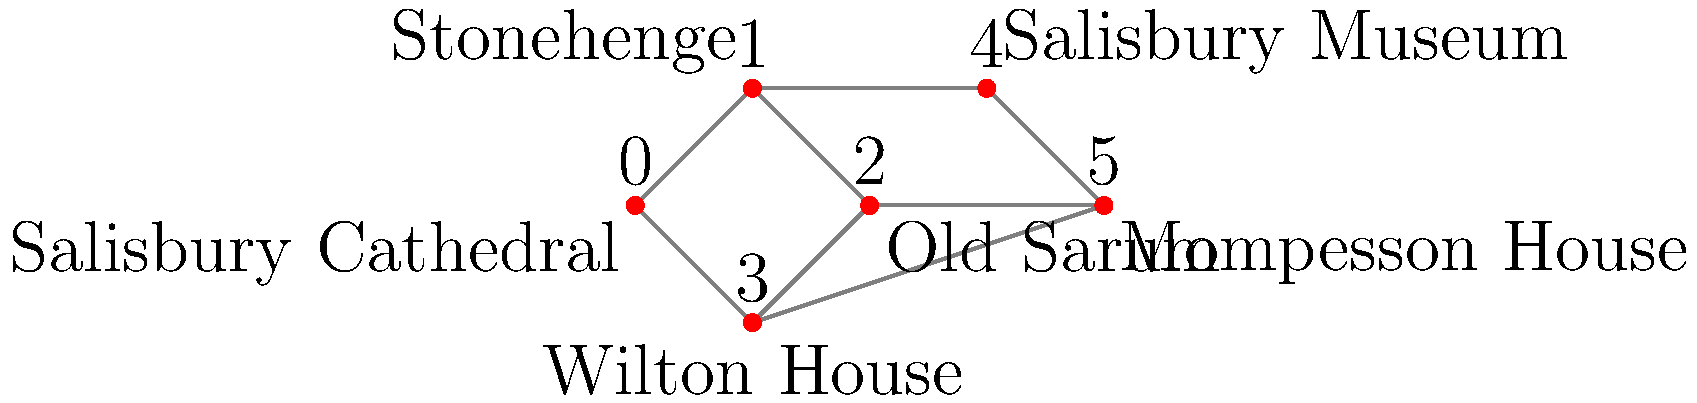Based on the network diagram of historical sites in Salisbury, which site has the highest degree centrality (i.e., is connected to the most other sites)? To determine which historical site has the highest degree centrality, we need to count the number of connections (edges) for each node in the network. Let's go through this step-by-step:

1. Salisbury Cathedral (node 0): Connected to 2 other sites (nodes 1 and 3)
2. Stonehenge (node 1): Connected to 3 other sites (nodes 0, 2, and 4)
3. Old Sarum (node 2): Connected to 3 other sites (nodes 1, 3, and 5)
4. Wilton House (node 3): Connected to 3 other sites (nodes 0, 2, and 5)
5. Salisbury Museum (node 4): Connected to 2 other sites (nodes 1 and 5)
6. Mompesson House (node 5): Connected to 3 other sites (nodes 2, 3, and 4)

We can see that Stonehenge (node 1), Old Sarum (node 2), Wilton House (node 3), and Mompesson House (node 5) all have the highest number of connections, with 3 edges each. However, since we need to choose one site, we'll select the one that appears first in the list, which is Stonehenge.

The degree centrality is a measure of how many direct connections a node has in a network. In this case, Stonehenge has the highest degree centrality, indicating its importance as a central hub in the network of historical sites in Salisbury.
Answer: Stonehenge 